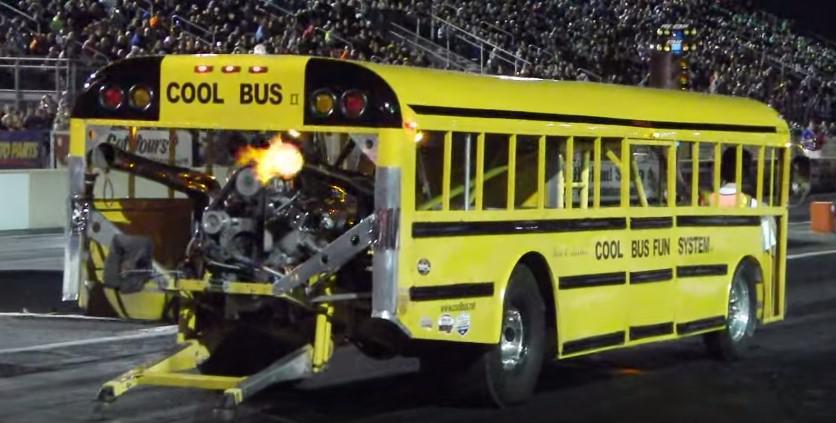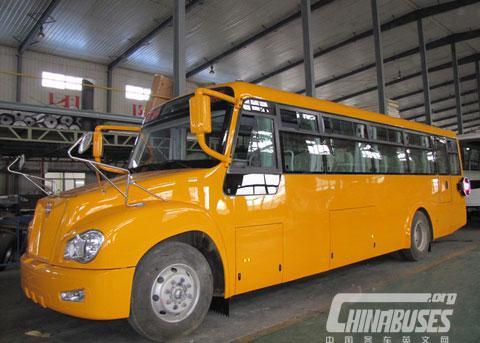The first image is the image on the left, the second image is the image on the right. Examine the images to the left and right. Is the description "One bus has wheels on its roof." accurate? Answer yes or no. No. The first image is the image on the left, the second image is the image on the right. Examine the images to the left and right. Is the description "The right image shows a sideways short bus with not more than three rectangular passenger windows, and the left image shows a bus with an inverted bus on its top." accurate? Answer yes or no. No. 